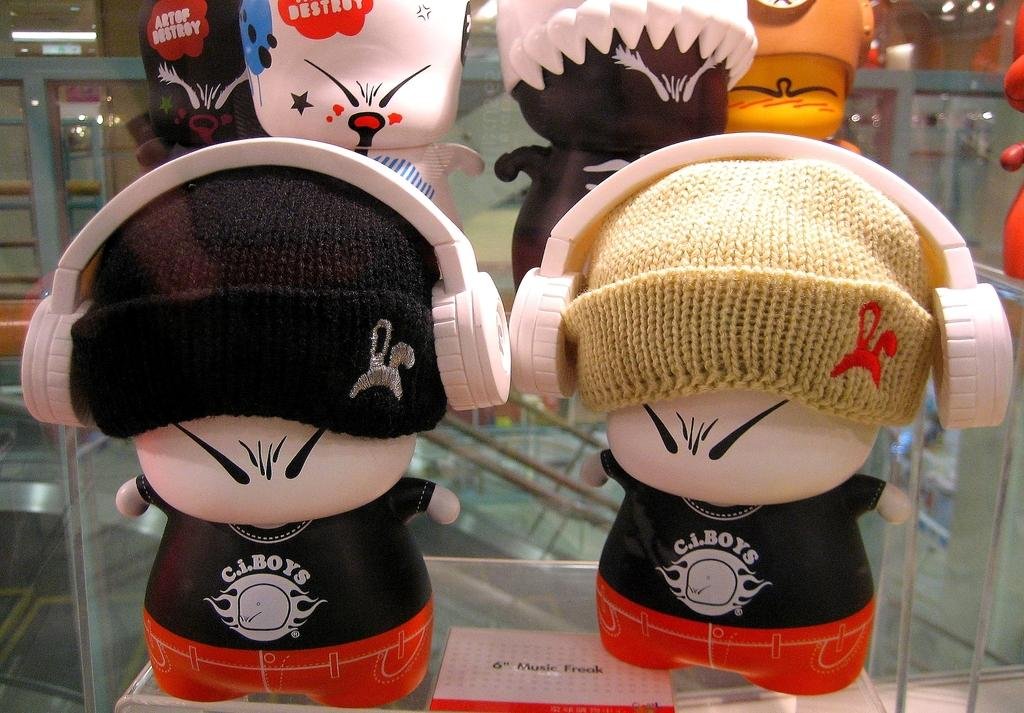What type of objects are placed on racks in the image? There are dolls placed on racks in the image. What can be seen hanging from the ceiling in the image? There are ceiling lights visible in the image. What shape is the neck of the doll on the left side of the image? There is no specific detail about the shape of the doll's neck provided in the image, and the image does not show a doll on the left side. 